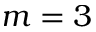Convert formula to latex. <formula><loc_0><loc_0><loc_500><loc_500>m = 3</formula> 